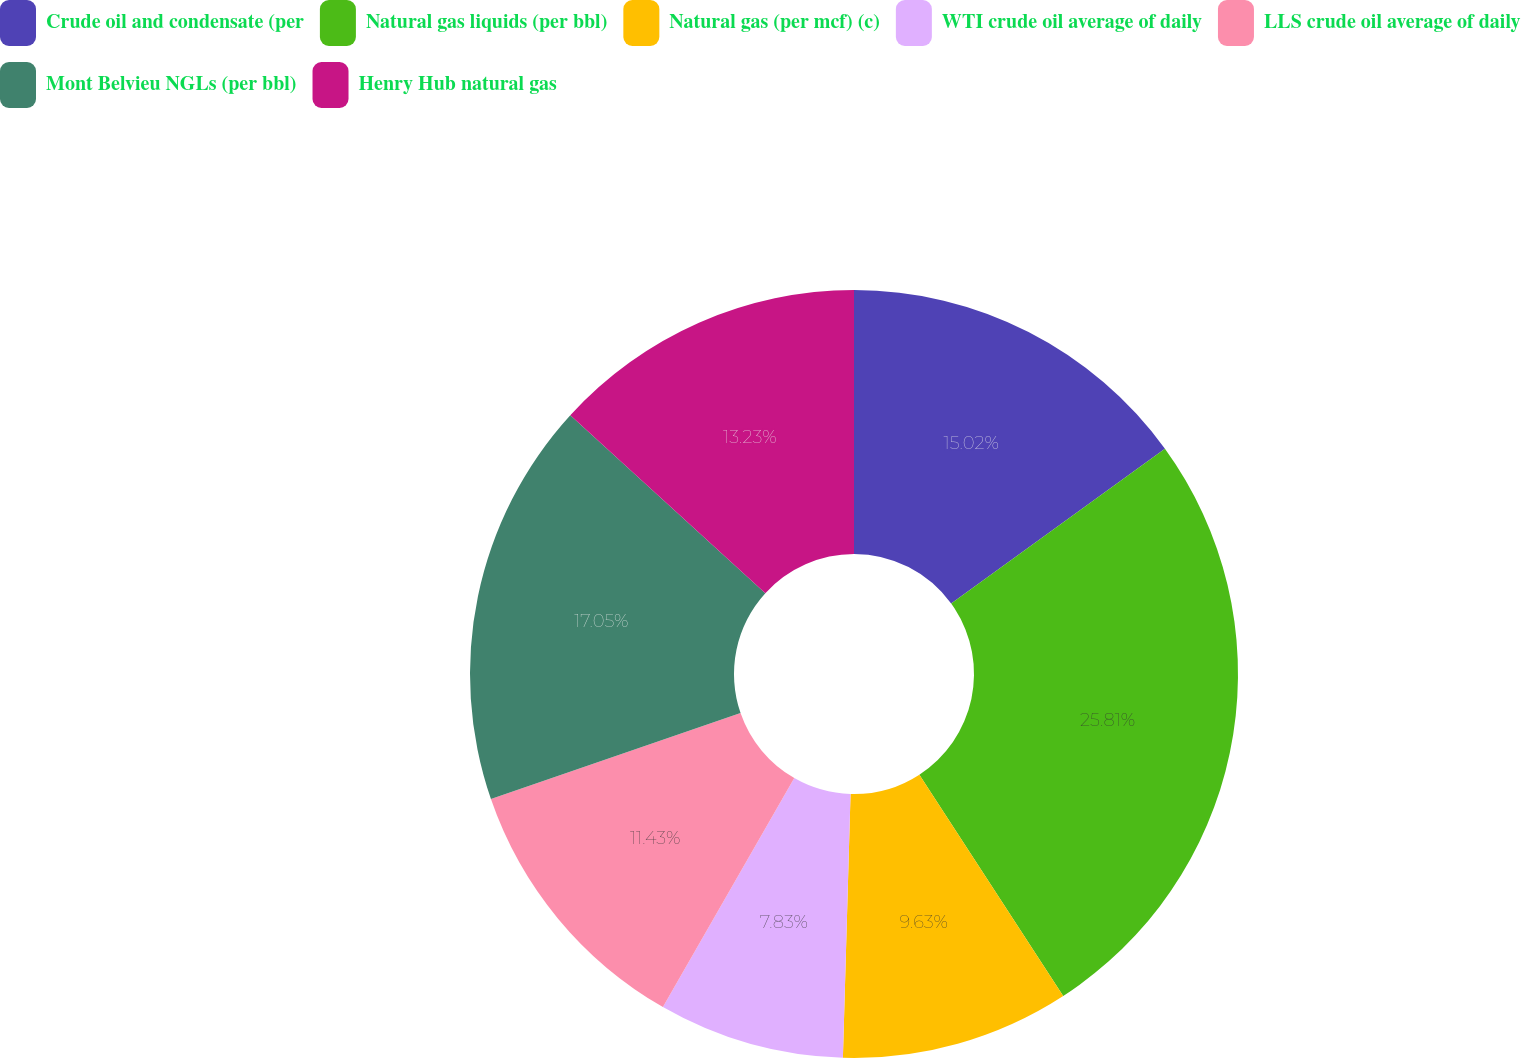Convert chart. <chart><loc_0><loc_0><loc_500><loc_500><pie_chart><fcel>Crude oil and condensate (per<fcel>Natural gas liquids (per bbl)<fcel>Natural gas (per mcf) (c)<fcel>WTI crude oil average of daily<fcel>LLS crude oil average of daily<fcel>Mont Belvieu NGLs (per bbl)<fcel>Henry Hub natural gas<nl><fcel>15.02%<fcel>25.81%<fcel>9.63%<fcel>7.83%<fcel>11.43%<fcel>17.05%<fcel>13.23%<nl></chart> 